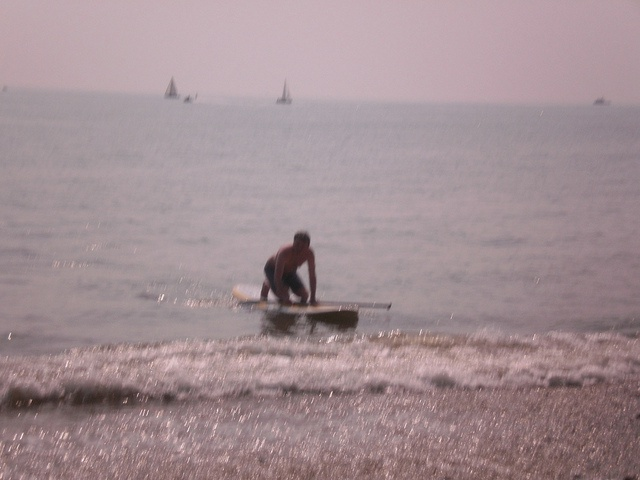Describe the objects in this image and their specific colors. I can see people in darkgray, black, and gray tones, surfboard in darkgray, gray, and black tones, boat in darkgray and gray tones, boat in darkgray and gray tones, and boat in darkgray and gray tones in this image. 